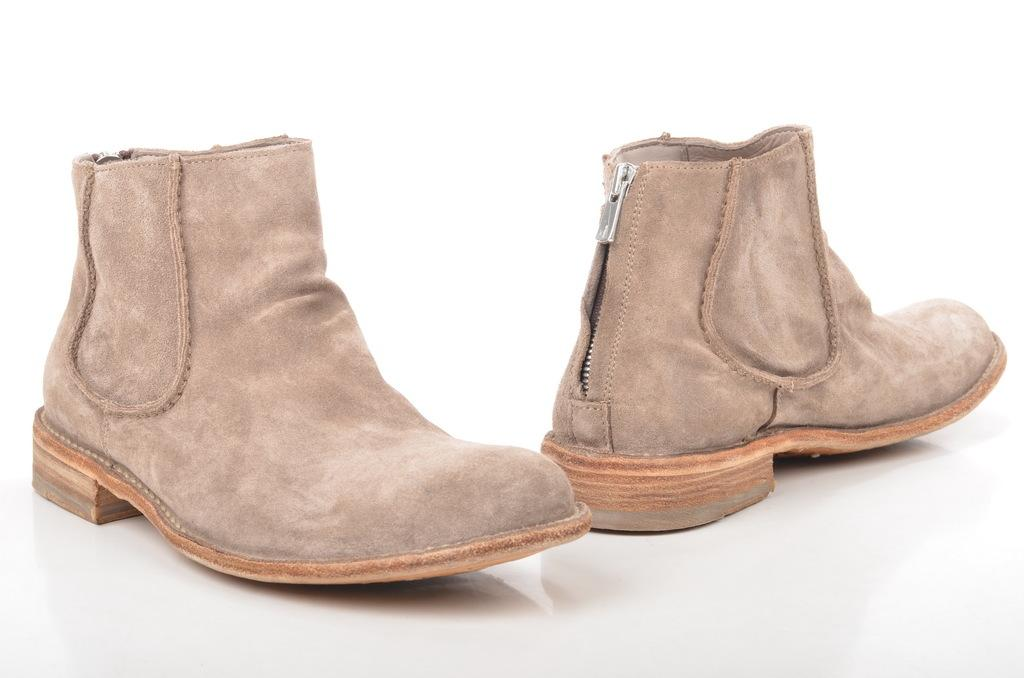What type of object is on the left side of the image? There is a brown color shoe on the left side of the image. Is there a similar object on the right side of the image? Yes, there is another shoe on the right side of the image. Where are the shoes placed in the image? Both shoes are on a surface. What color is the background of the image? The background of the image is white in color. What type of surprise can be seen in the image? There is no surprise present in the image; it features two shoes on a surface with a white background. Can you tell me how the army is involved in the image? There is no mention of an army or any military-related elements in the image. 